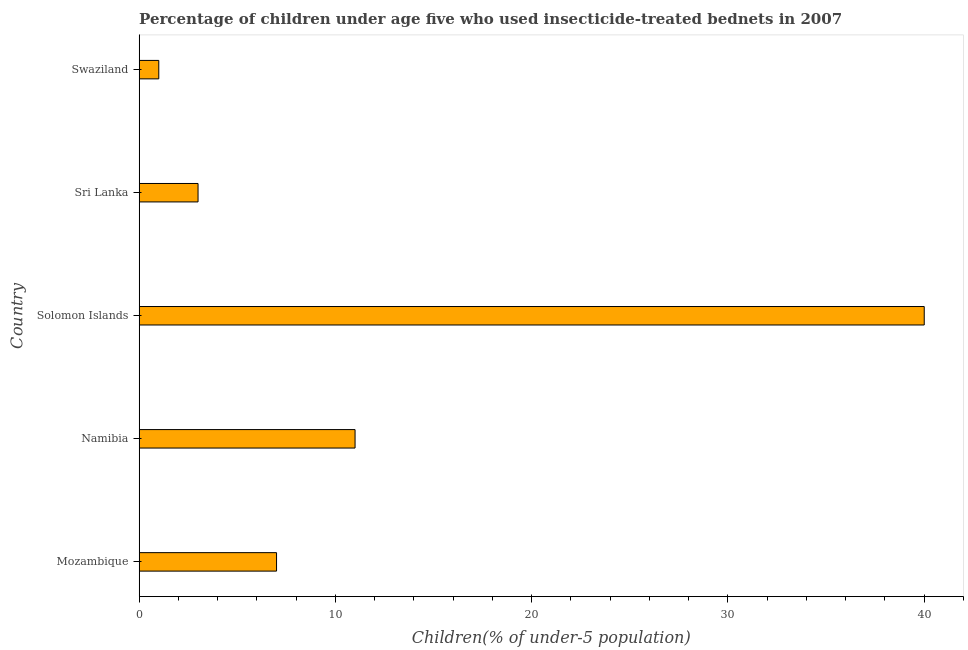Does the graph contain any zero values?
Ensure brevity in your answer.  No. What is the title of the graph?
Offer a very short reply. Percentage of children under age five who used insecticide-treated bednets in 2007. What is the label or title of the X-axis?
Make the answer very short. Children(% of under-5 population). What is the label or title of the Y-axis?
Offer a very short reply. Country. In which country was the percentage of children who use of insecticide-treated bed nets maximum?
Offer a very short reply. Solomon Islands. In which country was the percentage of children who use of insecticide-treated bed nets minimum?
Your answer should be very brief. Swaziland. What is the sum of the percentage of children who use of insecticide-treated bed nets?
Ensure brevity in your answer.  62. What is the difference between the percentage of children who use of insecticide-treated bed nets in Mozambique and Swaziland?
Ensure brevity in your answer.  6. What is the average percentage of children who use of insecticide-treated bed nets per country?
Offer a very short reply. 12.4. What is the median percentage of children who use of insecticide-treated bed nets?
Provide a succinct answer. 7. In how many countries, is the percentage of children who use of insecticide-treated bed nets greater than 26 %?
Your answer should be very brief. 1. What is the ratio of the percentage of children who use of insecticide-treated bed nets in Solomon Islands to that in Sri Lanka?
Offer a terse response. 13.33. Is the percentage of children who use of insecticide-treated bed nets in Sri Lanka less than that in Swaziland?
Your answer should be very brief. No. Is the sum of the percentage of children who use of insecticide-treated bed nets in Namibia and Sri Lanka greater than the maximum percentage of children who use of insecticide-treated bed nets across all countries?
Ensure brevity in your answer.  No. How many bars are there?
Provide a short and direct response. 5. What is the Children(% of under-5 population) of Solomon Islands?
Your answer should be very brief. 40. What is the difference between the Children(% of under-5 population) in Mozambique and Solomon Islands?
Your answer should be compact. -33. What is the difference between the Children(% of under-5 population) in Namibia and Sri Lanka?
Offer a very short reply. 8. What is the difference between the Children(% of under-5 population) in Solomon Islands and Sri Lanka?
Offer a very short reply. 37. What is the ratio of the Children(% of under-5 population) in Mozambique to that in Namibia?
Offer a very short reply. 0.64. What is the ratio of the Children(% of under-5 population) in Mozambique to that in Solomon Islands?
Offer a very short reply. 0.17. What is the ratio of the Children(% of under-5 population) in Mozambique to that in Sri Lanka?
Your answer should be very brief. 2.33. What is the ratio of the Children(% of under-5 population) in Mozambique to that in Swaziland?
Ensure brevity in your answer.  7. What is the ratio of the Children(% of under-5 population) in Namibia to that in Solomon Islands?
Your response must be concise. 0.28. What is the ratio of the Children(% of under-5 population) in Namibia to that in Sri Lanka?
Give a very brief answer. 3.67. What is the ratio of the Children(% of under-5 population) in Solomon Islands to that in Sri Lanka?
Provide a succinct answer. 13.33. What is the ratio of the Children(% of under-5 population) in Solomon Islands to that in Swaziland?
Offer a very short reply. 40. What is the ratio of the Children(% of under-5 population) in Sri Lanka to that in Swaziland?
Provide a short and direct response. 3. 